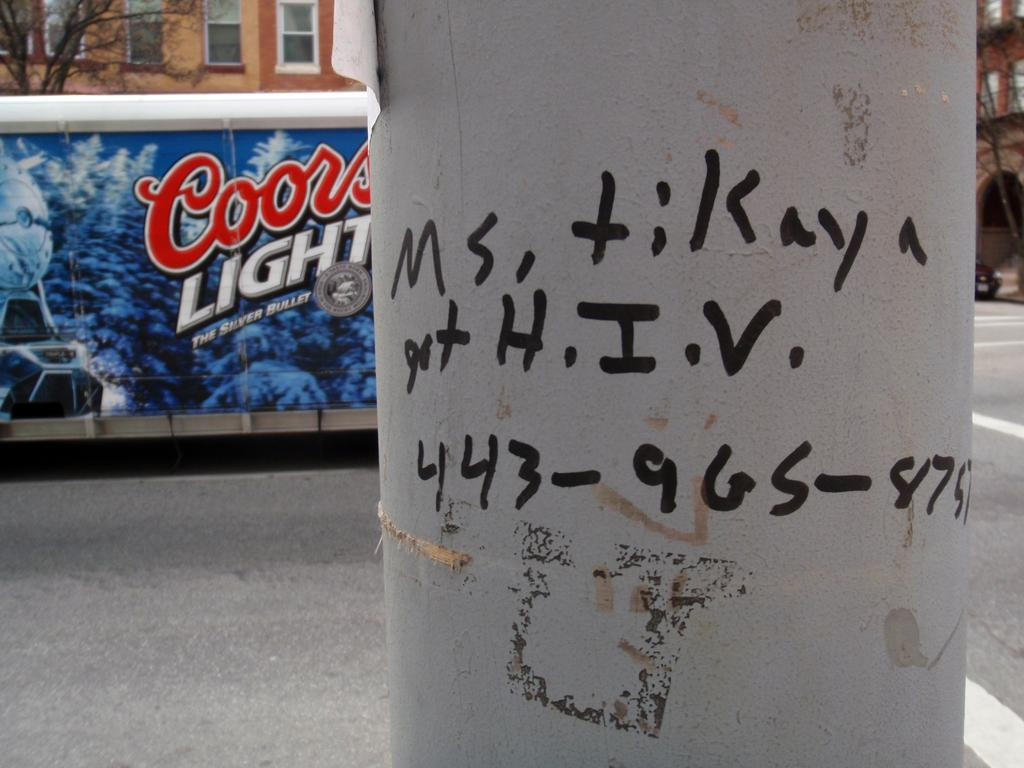What is written on the pole in the image? There are letters written on a pole in the image. What can be seen in the distance behind the pole? There are buildings, a poster, trees, a vehicle, and a road in the background of the image. What type of leg can be seen supporting the stove in the image? There is no stove or leg present in the image. 